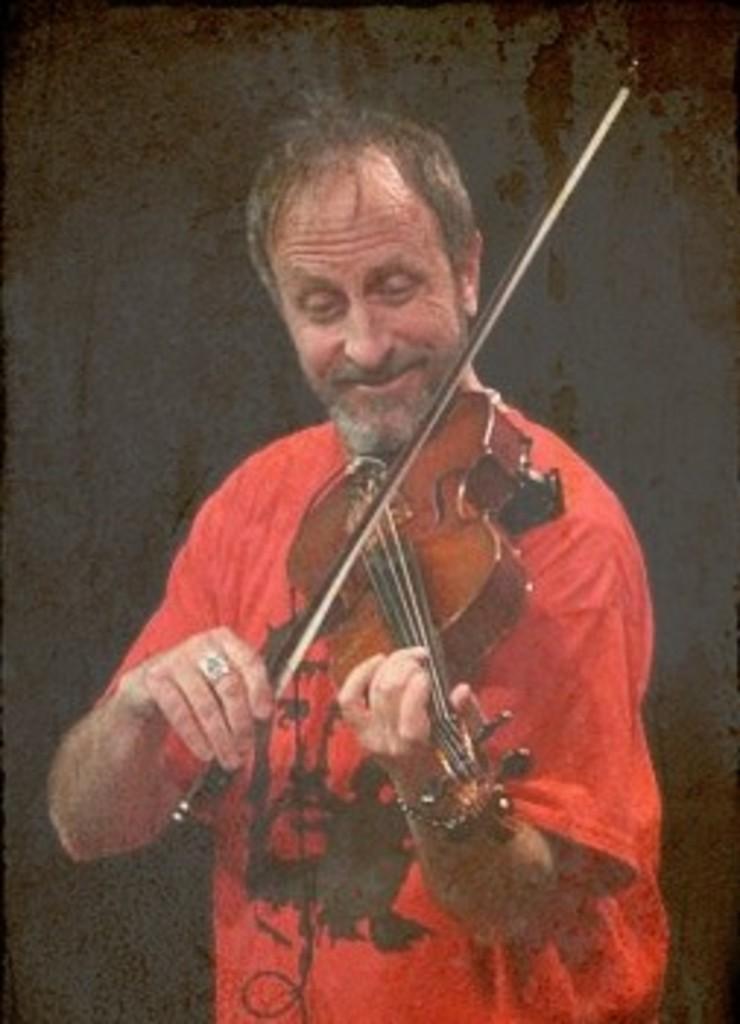In one or two sentences, can you explain what this image depicts? In this picture there is a man who is wearing red t-shirt, he is playing the violin by smiling, there is a black color background in the image behind the man. 